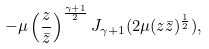Convert formula to latex. <formula><loc_0><loc_0><loc_500><loc_500>- \mu \left ( \frac { z } { \bar { z } } \right ) ^ { \frac { \gamma + 1 } { 2 } } J _ { \gamma + 1 } ( 2 \mu ( z \bar { z } ) ^ { \frac { 1 } { 2 } } ) ,</formula> 